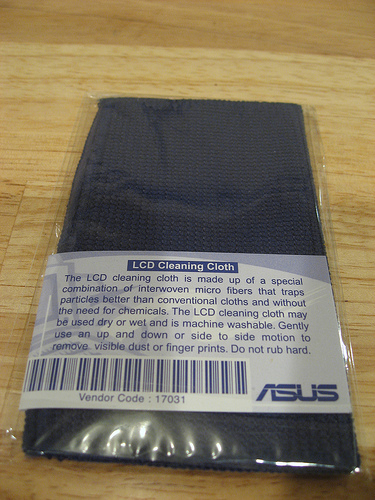<image>
Can you confirm if the cloth is on the table? Yes. Looking at the image, I can see the cloth is positioned on top of the table, with the table providing support. 